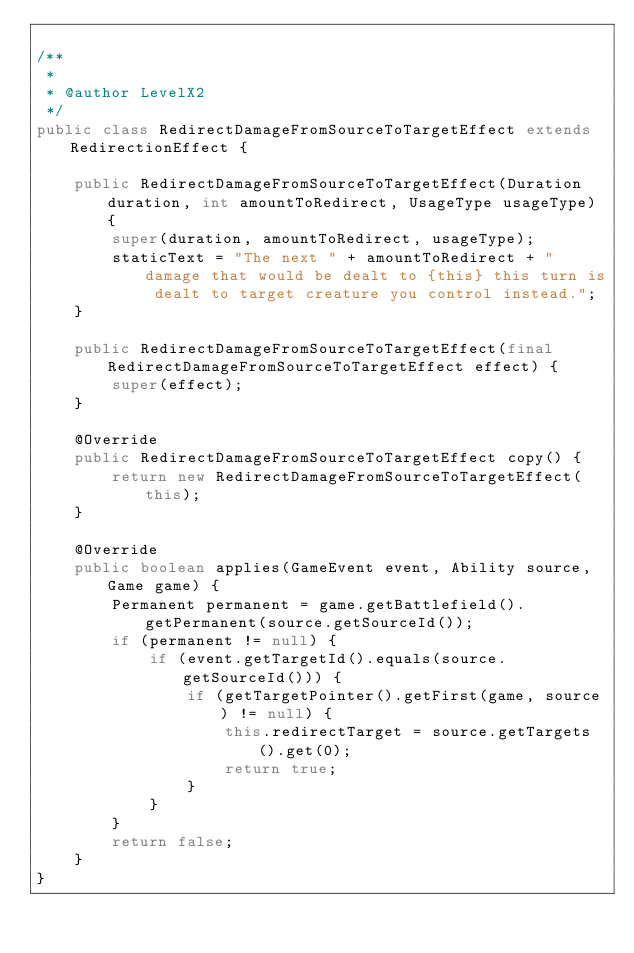Convert code to text. <code><loc_0><loc_0><loc_500><loc_500><_Java_>
/**
 *
 * @author LevelX2
 */
public class RedirectDamageFromSourceToTargetEffect extends RedirectionEffect {

    public RedirectDamageFromSourceToTargetEffect(Duration duration, int amountToRedirect, UsageType usageType) {
        super(duration, amountToRedirect, usageType);
        staticText = "The next " + amountToRedirect + " damage that would be dealt to {this} this turn is dealt to target creature you control instead.";
    }

    public RedirectDamageFromSourceToTargetEffect(final RedirectDamageFromSourceToTargetEffect effect) {
        super(effect);
    }

    @Override
    public RedirectDamageFromSourceToTargetEffect copy() {
        return new RedirectDamageFromSourceToTargetEffect(this);
    }

    @Override
    public boolean applies(GameEvent event, Ability source, Game game) {
        Permanent permanent = game.getBattlefield().getPermanent(source.getSourceId());
        if (permanent != null) {
            if (event.getTargetId().equals(source.getSourceId())) {
                if (getTargetPointer().getFirst(game, source) != null) {
                    this.redirectTarget = source.getTargets().get(0);
                    return true;
                }
            }
        }
        return false;
    }
}
</code> 